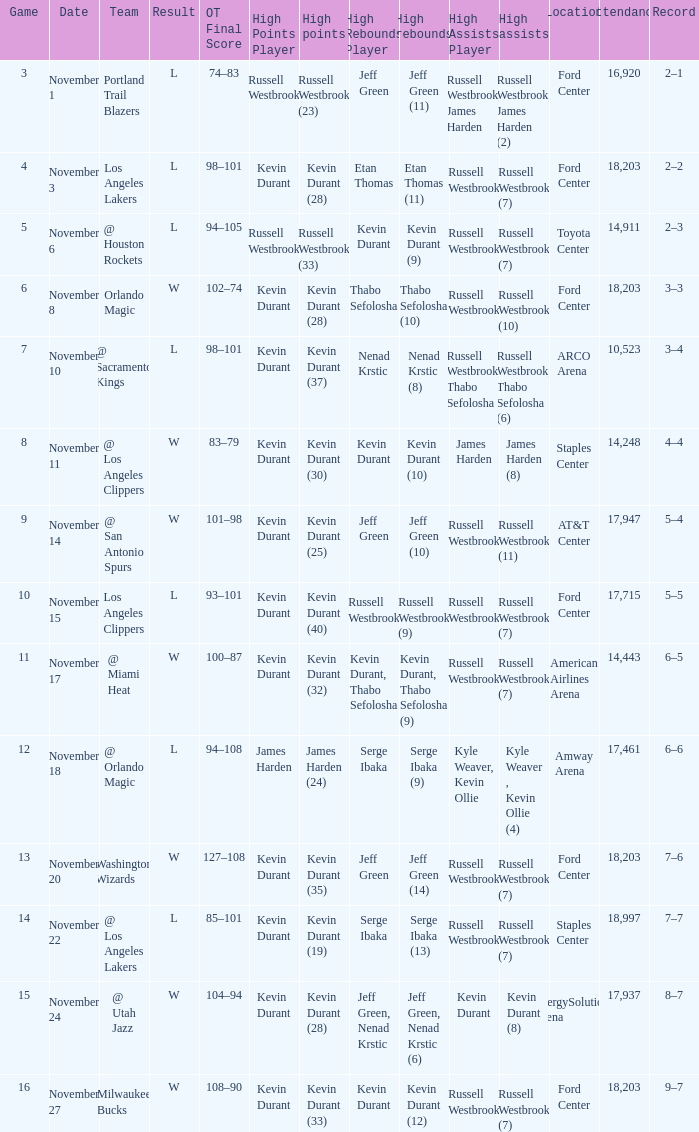When was the game number 3 played? November 1. Could you parse the entire table? {'header': ['Game', 'Date', 'Team', 'Result', 'OT Final Score', 'High Points Player', 'High points', 'High Rebounds Player', 'High rebounds', 'High Assists Player', 'High assists', 'Location', 'Attendance', 'Record'], 'rows': [['3', 'November 1', 'Portland Trail Blazers', 'L', '74–83', 'Russell Westbrook', 'Russell Westbrook (23)', 'Jeff Green', 'Jeff Green (11)', 'Russell Westbrook, James Harden', 'Russell Westbrook, James Harden (2)', 'Ford Center', '16,920', '2–1'], ['4', 'November 3', 'Los Angeles Lakers', 'L', '98–101', 'Kevin Durant', 'Kevin Durant (28)', 'Etan Thomas', 'Etan Thomas (11)', 'Russell Westbrook', 'Russell Westbrook (7)', 'Ford Center', '18,203', '2–2'], ['5', 'November 6', '@ Houston Rockets', 'L', '94–105', 'Russell Westbrook', 'Russell Westbrook (33)', 'Kevin Durant', 'Kevin Durant (9)', 'Russell Westbrook', 'Russell Westbrook (7)', 'Toyota Center', '14,911', '2–3'], ['6', 'November 8', 'Orlando Magic', 'W', '102–74', 'Kevin Durant', 'Kevin Durant (28)', 'Thabo Sefolosha', 'Thabo Sefolosha (10)', 'Russell Westbrook', 'Russell Westbrook (10)', 'Ford Center', '18,203', '3–3'], ['7', 'November 10', '@ Sacramento Kings', 'L', '98–101', 'Kevin Durant', 'Kevin Durant (37)', 'Nenad Krstic', 'Nenad Krstic (8)', 'Russell Westbrook, Thabo Sefolosha', 'Russell Westbrook, Thabo Sefolosha (6)', 'ARCO Arena', '10,523', '3–4'], ['8', 'November 11', '@ Los Angeles Clippers', 'W', '83–79', 'Kevin Durant', 'Kevin Durant (30)', 'Kevin Durant', 'Kevin Durant (10)', 'James Harden', 'James Harden (8)', 'Staples Center', '14,248', '4–4'], ['9', 'November 14', '@ San Antonio Spurs', 'W', '101–98', 'Kevin Durant', 'Kevin Durant (25)', 'Jeff Green', 'Jeff Green (10)', 'Russell Westbrook', 'Russell Westbrook (11)', 'AT&T Center', '17,947', '5–4'], ['10', 'November 15', 'Los Angeles Clippers', 'L', '93–101', 'Kevin Durant', 'Kevin Durant (40)', 'Russell Westbrook', 'Russell Westbrook (9)', 'Russell Westbrook', 'Russell Westbrook (7)', 'Ford Center', '17,715', '5–5'], ['11', 'November 17', '@ Miami Heat', 'W', '100–87', 'Kevin Durant', 'Kevin Durant (32)', 'Kevin Durant, Thabo Sefolosha', 'Kevin Durant, Thabo Sefolosha (9)', 'Russell Westbrook', 'Russell Westbrook (7)', 'American Airlines Arena', '14,443', '6–5'], ['12', 'November 18', '@ Orlando Magic', 'L', '94–108', 'James Harden', 'James Harden (24)', 'Serge Ibaka', 'Serge Ibaka (9)', 'Kyle Weaver, Kevin Ollie', 'Kyle Weaver , Kevin Ollie (4)', 'Amway Arena', '17,461', '6–6'], ['13', 'November 20', 'Washington Wizards', 'W', '127–108', 'Kevin Durant', 'Kevin Durant (35)', 'Jeff Green', 'Jeff Green (14)', 'Russell Westbrook', 'Russell Westbrook (7)', 'Ford Center', '18,203', '7–6'], ['14', 'November 22', '@ Los Angeles Lakers', 'L', '85–101', 'Kevin Durant', 'Kevin Durant (19)', 'Serge Ibaka', 'Serge Ibaka (13)', 'Russell Westbrook', 'Russell Westbrook (7)', 'Staples Center', '18,997', '7–7'], ['15', 'November 24', '@ Utah Jazz', 'W', '104–94', 'Kevin Durant', 'Kevin Durant (28)', 'Jeff Green, Nenad Krstic', 'Jeff Green, Nenad Krstic (6)', 'Kevin Durant', 'Kevin Durant (8)', 'EnergySolutions Arena', '17,937', '8–7'], ['16', 'November 27', 'Milwaukee Bucks', 'W', '108–90', 'Kevin Durant', 'Kevin Durant (33)', 'Kevin Durant', 'Kevin Durant (12)', 'Russell Westbrook', 'Russell Westbrook (7)', 'Ford Center', '18,203', '9–7']]} 